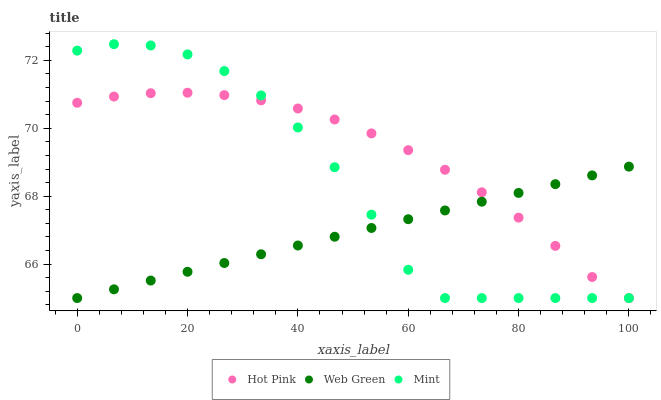Does Web Green have the minimum area under the curve?
Answer yes or no. Yes. Does Hot Pink have the maximum area under the curve?
Answer yes or no. Yes. Does Mint have the minimum area under the curve?
Answer yes or no. No. Does Mint have the maximum area under the curve?
Answer yes or no. No. Is Web Green the smoothest?
Answer yes or no. Yes. Is Mint the roughest?
Answer yes or no. Yes. Is Mint the smoothest?
Answer yes or no. No. Is Web Green the roughest?
Answer yes or no. No. Does Hot Pink have the lowest value?
Answer yes or no. Yes. Does Mint have the highest value?
Answer yes or no. Yes. Does Web Green have the highest value?
Answer yes or no. No. Does Web Green intersect Mint?
Answer yes or no. Yes. Is Web Green less than Mint?
Answer yes or no. No. Is Web Green greater than Mint?
Answer yes or no. No. 